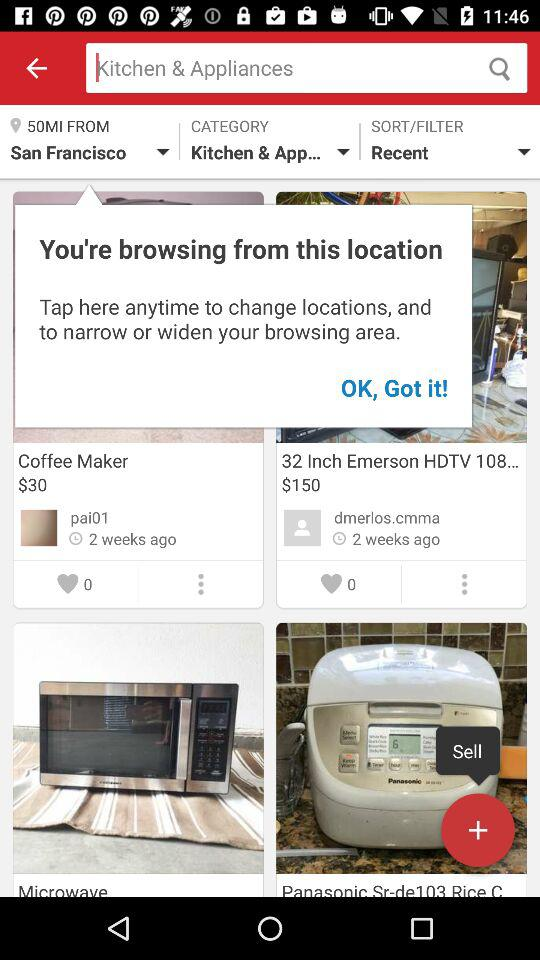What is the selected category? The selected category is "Kitchen & App...". 